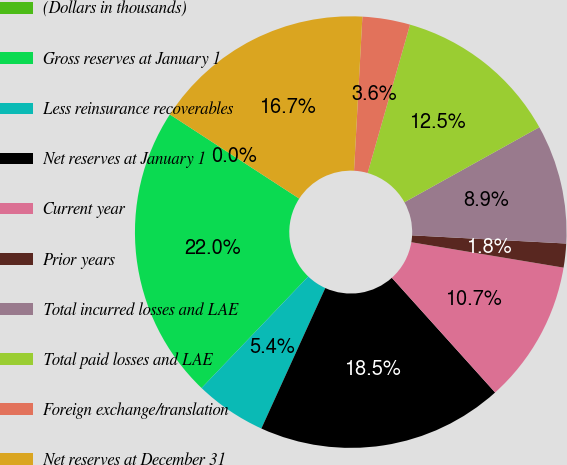<chart> <loc_0><loc_0><loc_500><loc_500><pie_chart><fcel>(Dollars in thousands)<fcel>Gross reserves at January 1<fcel>Less reinsurance recoverables<fcel>Net reserves at January 1<fcel>Current year<fcel>Prior years<fcel>Total incurred losses and LAE<fcel>Total paid losses and LAE<fcel>Foreign exchange/translation<fcel>Net reserves at December 31<nl><fcel>0.0%<fcel>22.03%<fcel>5.35%<fcel>18.46%<fcel>10.7%<fcel>1.79%<fcel>8.92%<fcel>12.49%<fcel>3.57%<fcel>16.68%<nl></chart> 